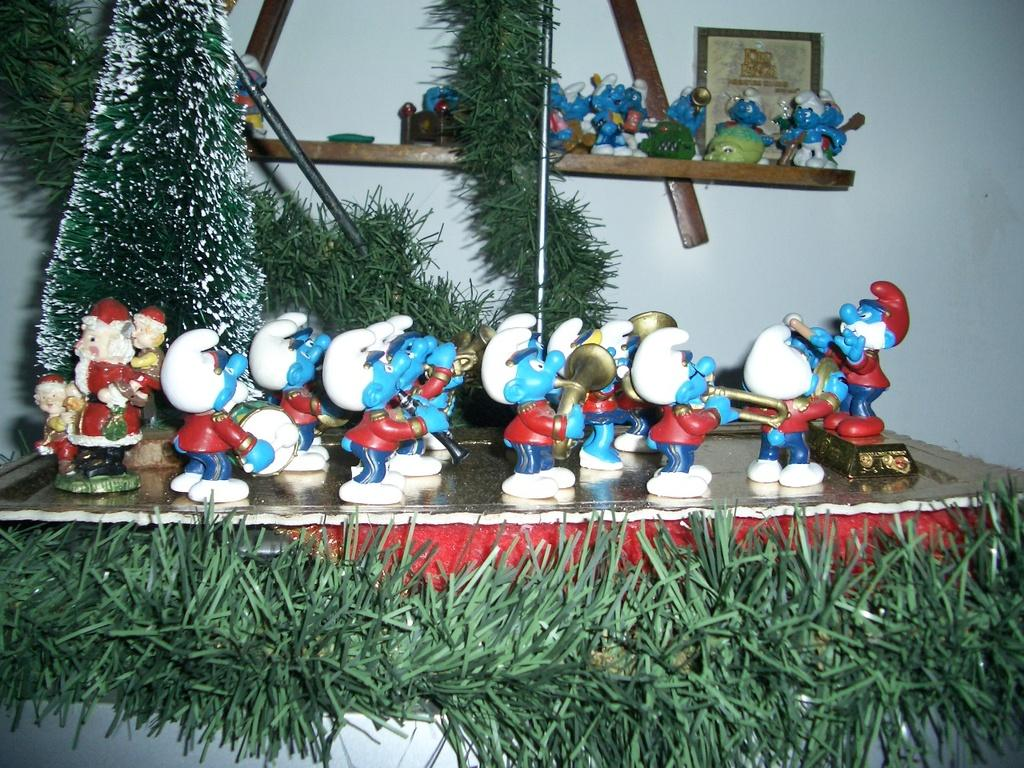What objects can be seen in the image? There are toys in the image. What type of natural environment is visible in the image? There is grass in the image. What can be seen in the background of the image? There is a frame and a wall in the background of the image. What type of celery is being used as a skirt in the image? There is no celery or skirt present in the image. What religious symbols can be seen in the image? There are no religious symbols present in the image. 